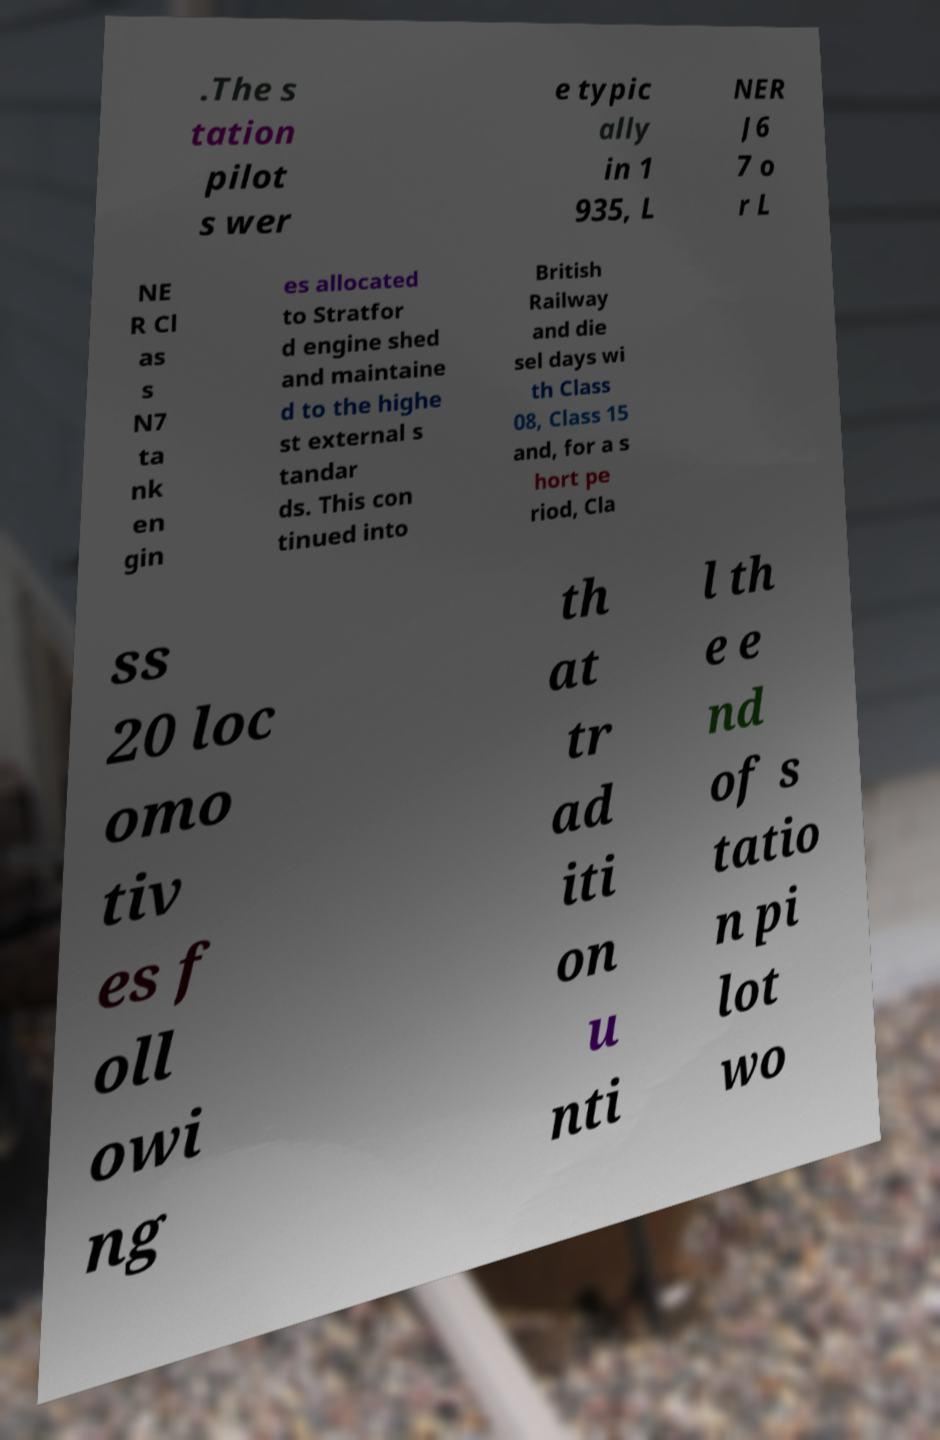For documentation purposes, I need the text within this image transcribed. Could you provide that? .The s tation pilot s wer e typic ally in 1 935, L NER J6 7 o r L NE R Cl as s N7 ta nk en gin es allocated to Stratfor d engine shed and maintaine d to the highe st external s tandar ds. This con tinued into British Railway and die sel days wi th Class 08, Class 15 and, for a s hort pe riod, Cla ss 20 loc omo tiv es f oll owi ng th at tr ad iti on u nti l th e e nd of s tatio n pi lot wo 